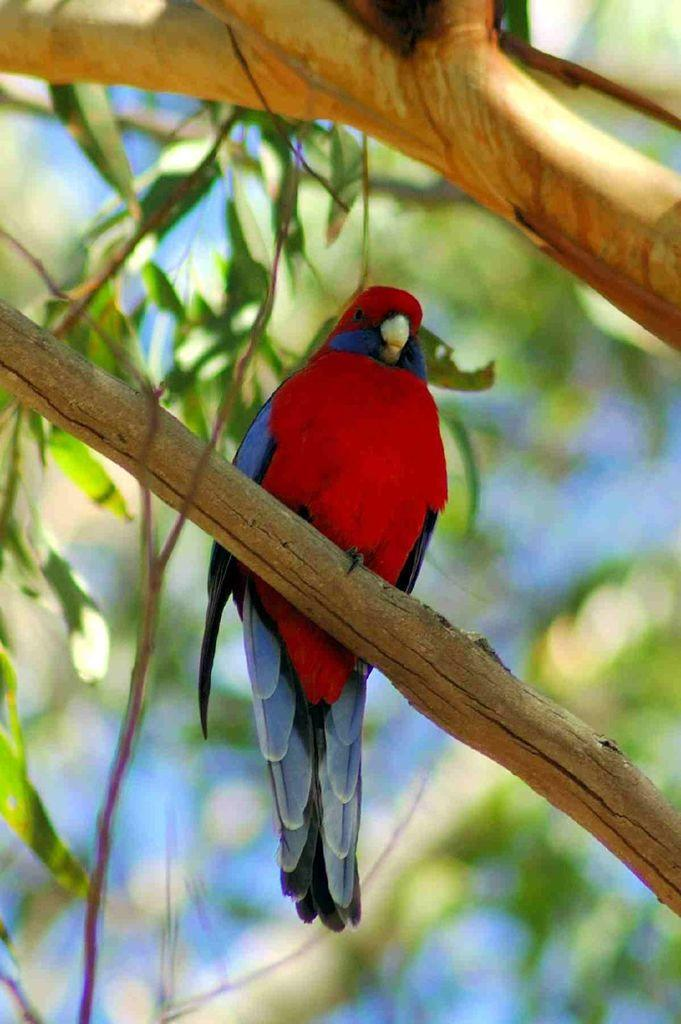What type of animal can be seen in the image? There is a bird in the image. Where is the bird located? The bird is on a tree. Can you describe the background of the image? The background of the image is blurred. How much honey does the bird have in its nest in the image? There is no nest or honey mentioned in the image; it only shows a bird on a tree with a blurred background. 